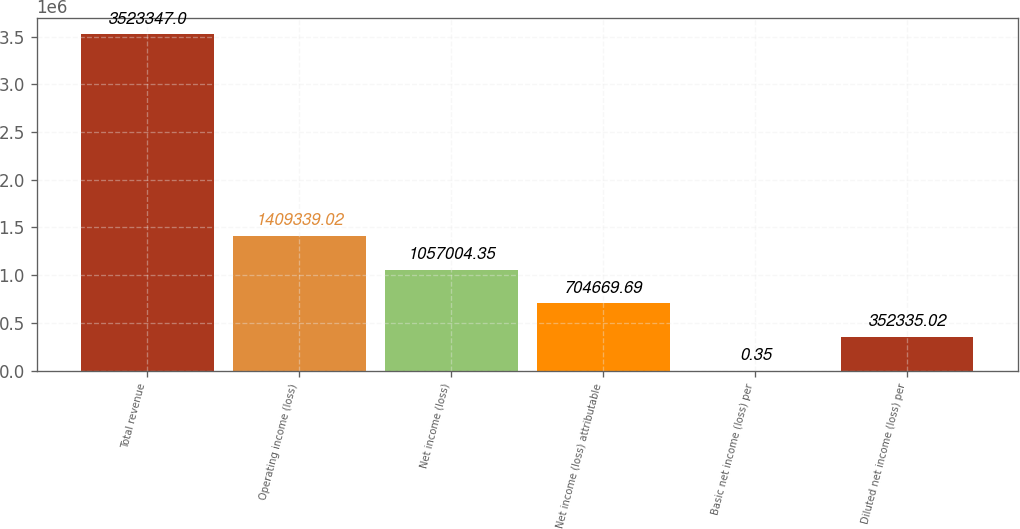<chart> <loc_0><loc_0><loc_500><loc_500><bar_chart><fcel>Total revenue<fcel>Operating income (loss)<fcel>Net income (loss)<fcel>Net income (loss) attributable<fcel>Basic net income (loss) per<fcel>Diluted net income (loss) per<nl><fcel>3.52335e+06<fcel>1.40934e+06<fcel>1.057e+06<fcel>704670<fcel>0.35<fcel>352335<nl></chart> 